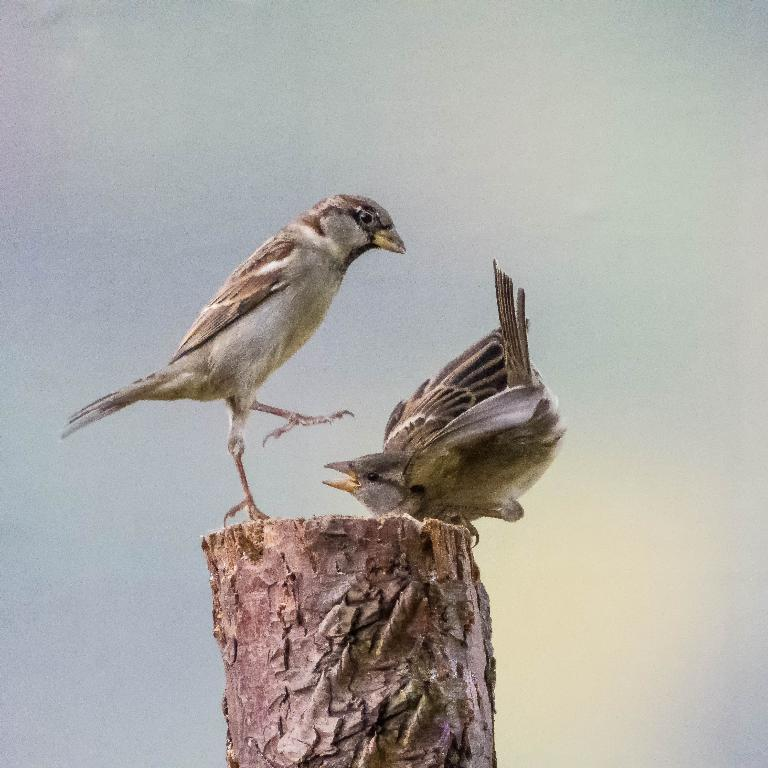How many birds can be seen in the image? There are two birds in the image. What are the birds doing in the image? The birds are standing on the trunk of a tree. What type of ball can be seen rolling through the image? There is no ball present in the image; it features two birds standing on a tree trunk. 